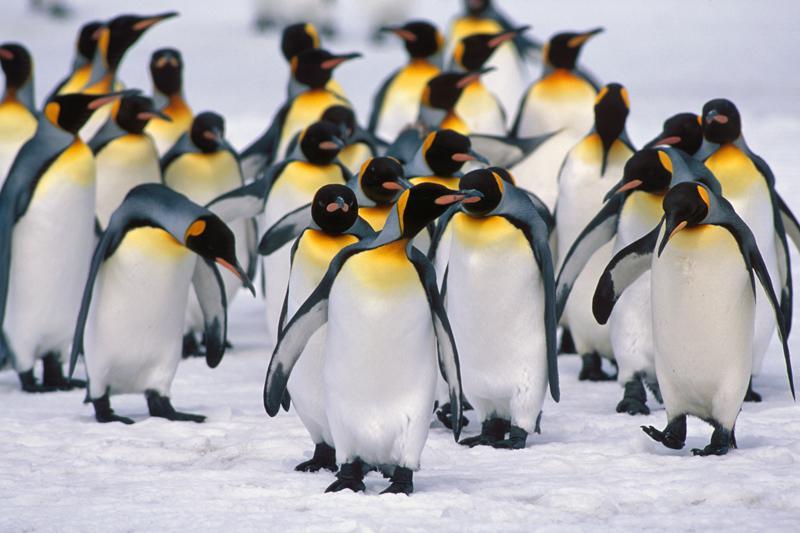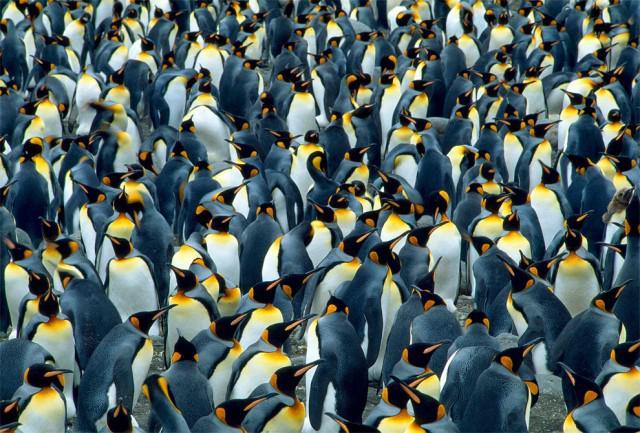The first image is the image on the left, the second image is the image on the right. Considering the images on both sides, is "One of the images must contain at least one hundred penguins." valid? Answer yes or no. Yes. The first image is the image on the left, the second image is the image on the right. Evaluate the accuracy of this statement regarding the images: "At least one of the penguins has an open beak in one of the images.". Is it true? Answer yes or no. No. 